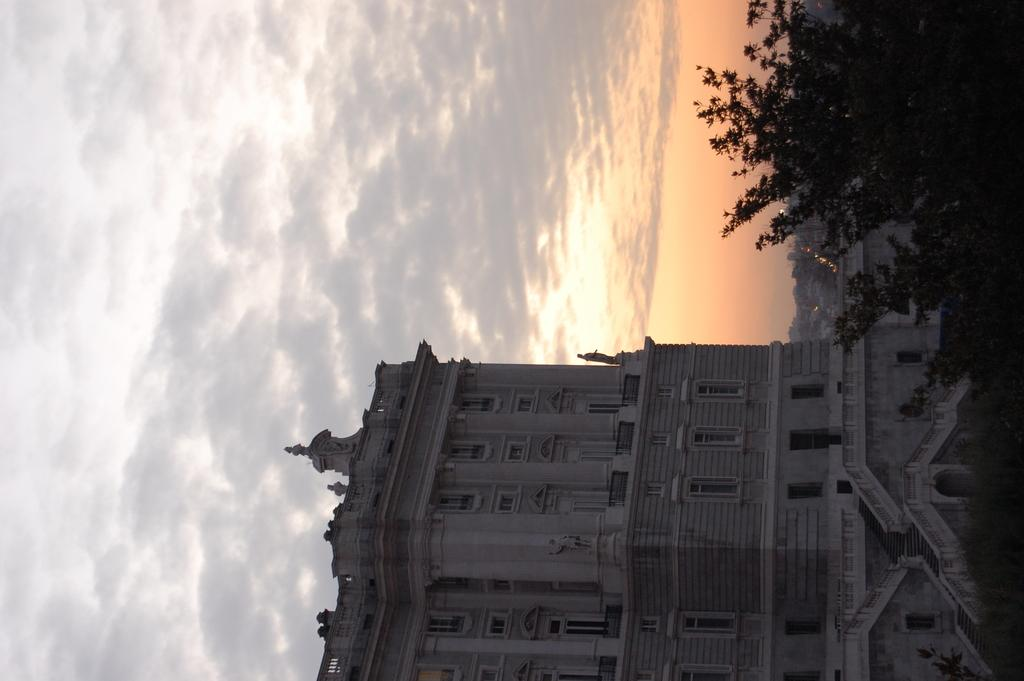What type of structure is in the image? There is a building in the image. What can be seen in the top right corner of the image? Trees are visible in the top right corner of the image. What else can be seen in the background of the image? There are buildings visible in the background of the image. What is visible at the top of the image? The sky is visible at the top of the image. What can be observed in the sky? Clouds are present in the sky. How many weeks does it take for the clouds to pass by in the image? The image is a still photograph, so it does not depict the passage of time or the movement of clouds. Therefore, it is not possible to determine how many weeks it would take for the clouds to pass by in the image. 